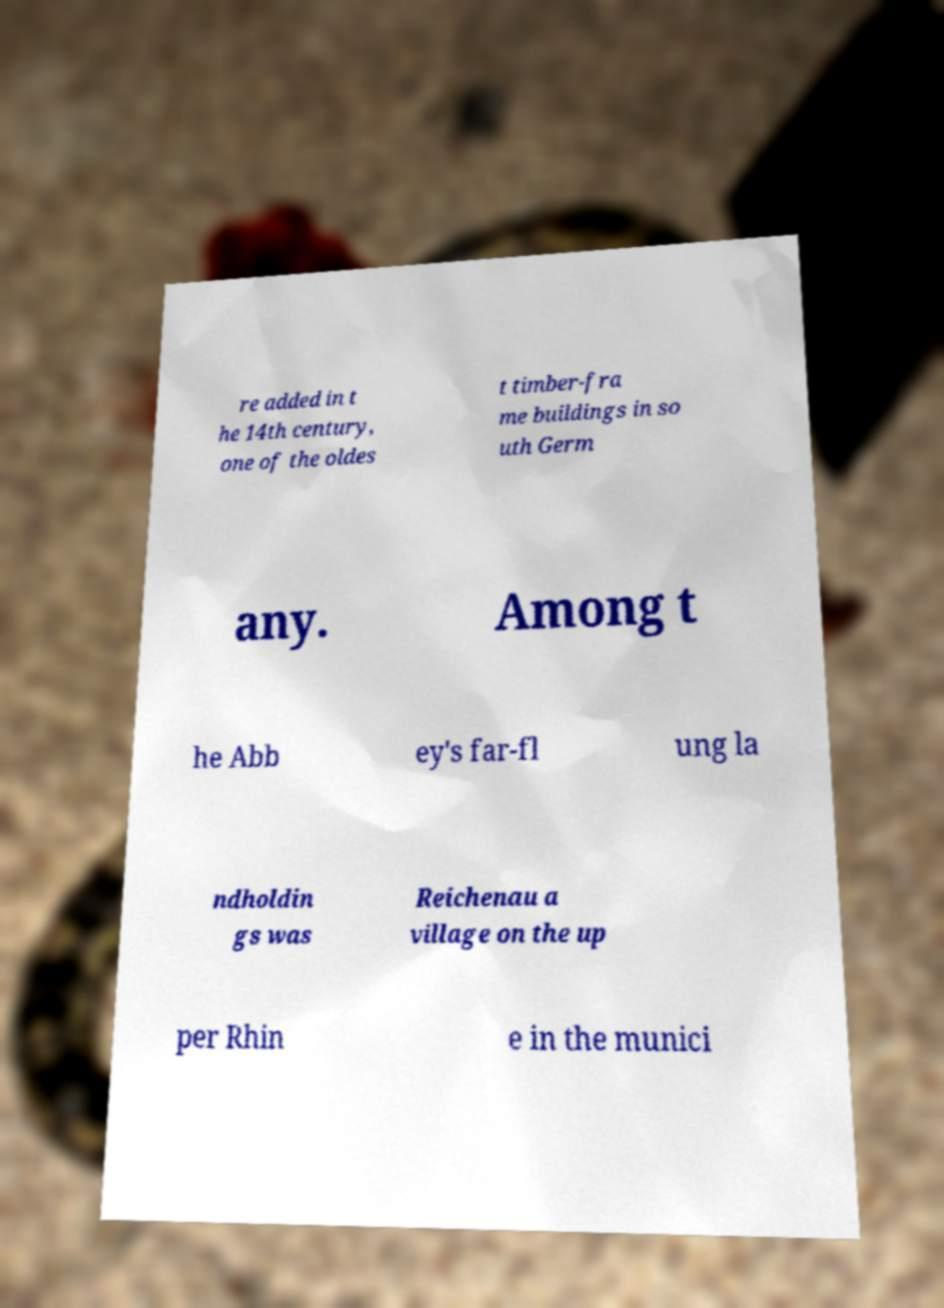Please read and relay the text visible in this image. What does it say? re added in t he 14th century, one of the oldes t timber-fra me buildings in so uth Germ any. Among t he Abb ey's far-fl ung la ndholdin gs was Reichenau a village on the up per Rhin e in the munici 